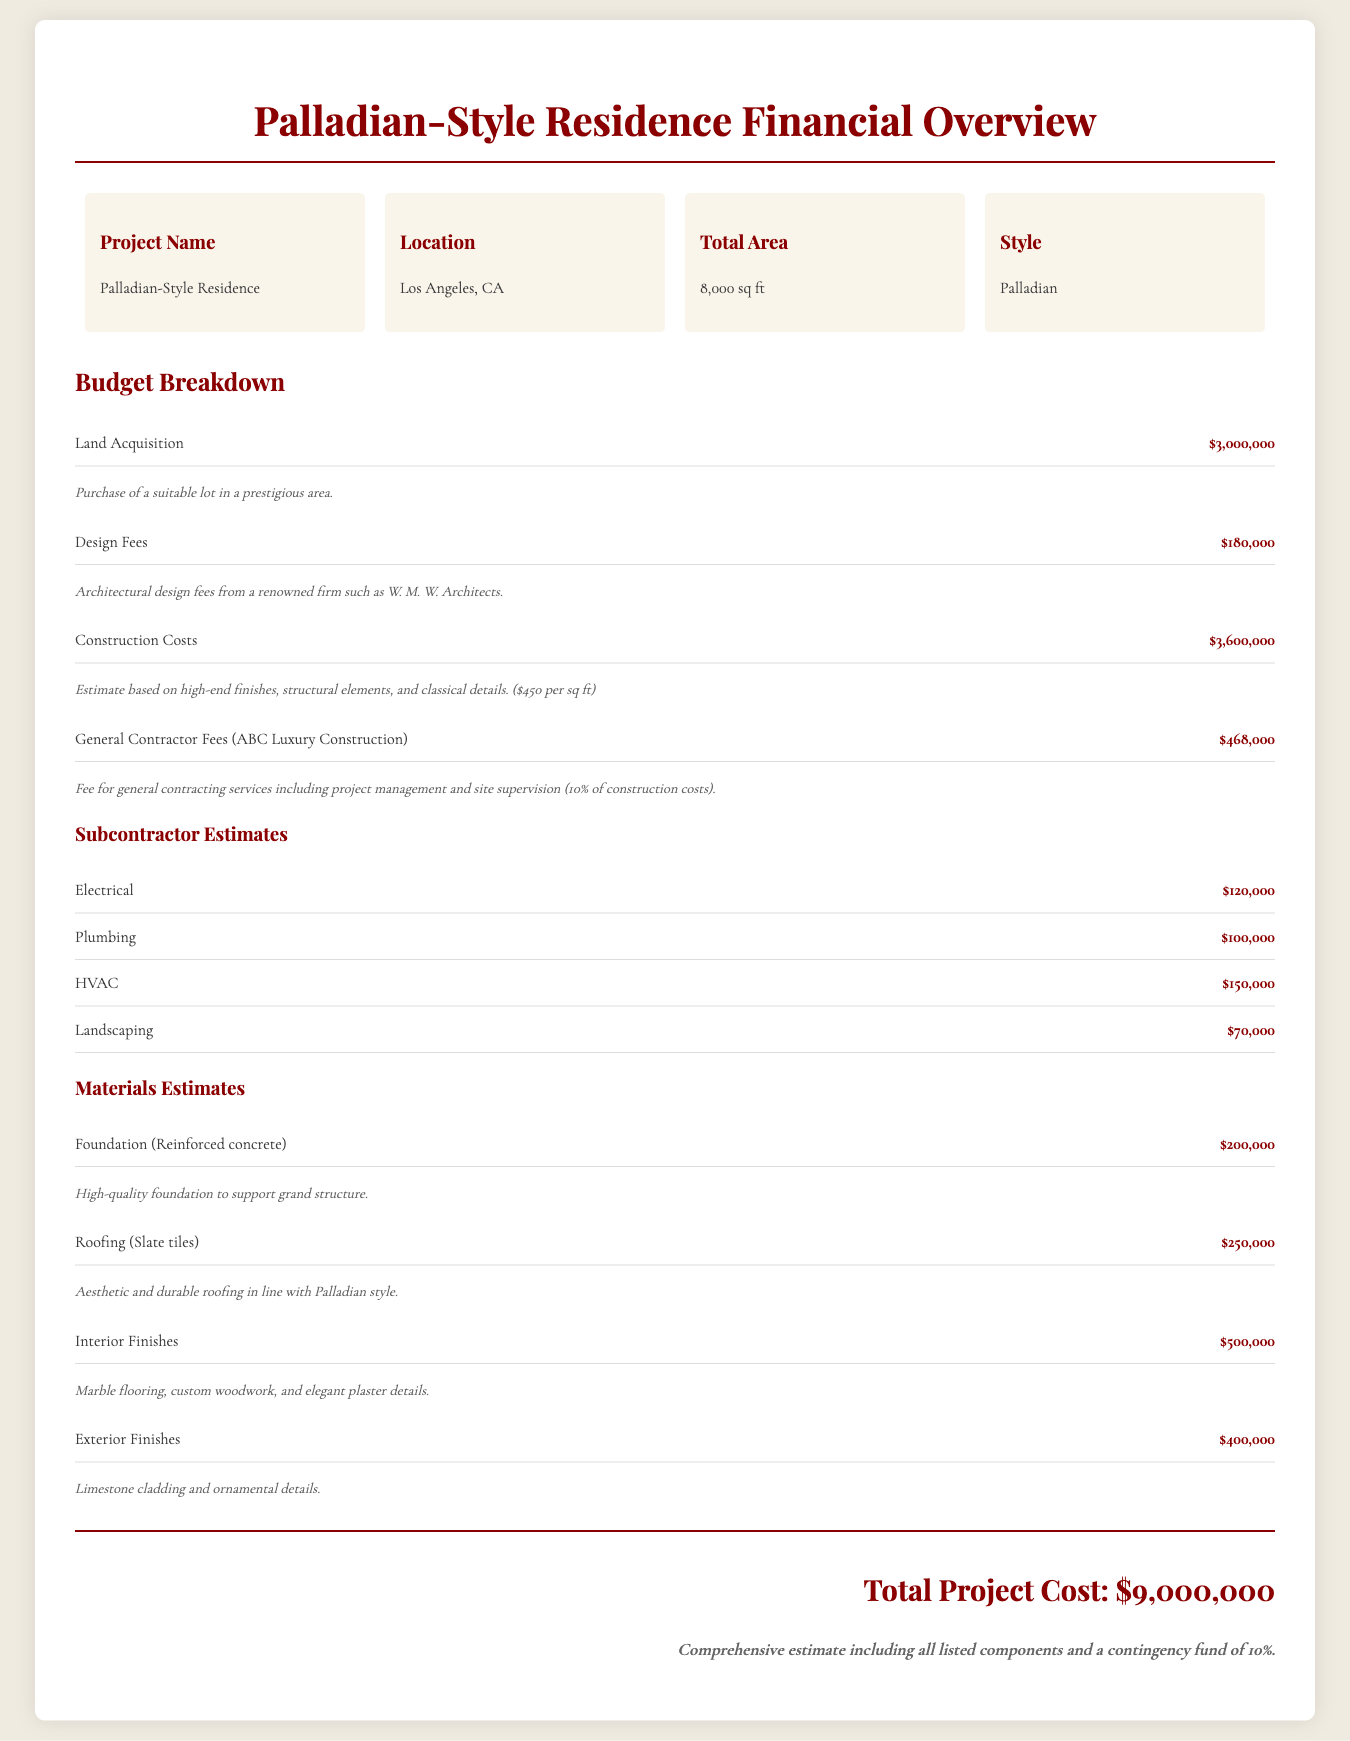What is the location of the project? The location is stated in the overview section of the document, which is Los Angeles, CA.
Answer: Los Angeles, CA What are the total construction costs? The total construction costs are listed under budget breakdown as $3,600,000.
Answer: $3,600,000 Who is the general contractor? The general contractor is mentioned in the budget breakdown as ABC Luxury Construction.
Answer: ABC Luxury Construction What is the estimated cost for electrical work? The document provides the estimated cost for electrical work under subcontractor estimates, listing it as $120,000.
Answer: $120,000 How much is allocated for landscaping? The budget breakdown specifies that the allocation for landscaping is $70,000.
Answer: $70,000 What is the total project cost? The total project cost at the bottom of the document sums all the expenses, given as $9,000,000.
Answer: $9,000,000 What percentage of construction costs is the general contractor fee? The document states that the general contractor fee is 10% of the construction costs.
Answer: 10% What are the materials estimated for roofing? The materials estimate section specifically mentions slate tiles for roofing at a cost of $250,000.
Answer: Slate tiles What is included in interior finishes? The description states that the interior finishes include marble flooring, custom woodwork, and elegant plaster details.
Answer: Marble flooring, custom woodwork, and elegant plaster details 